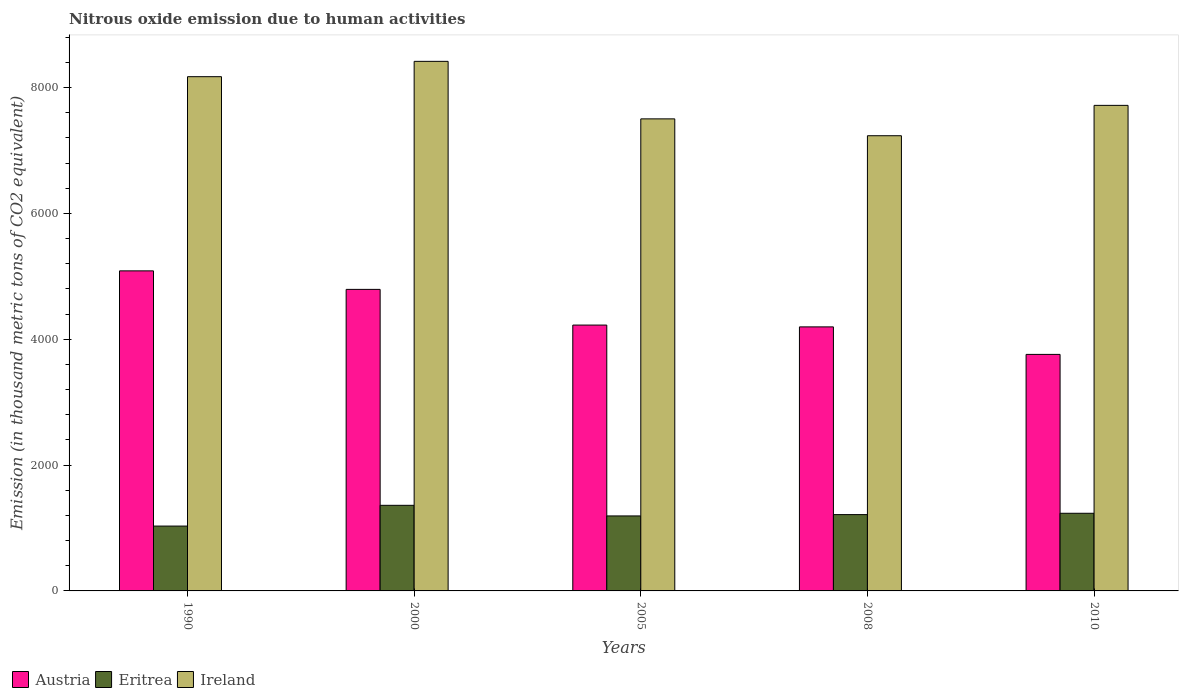How many different coloured bars are there?
Keep it short and to the point. 3. Are the number of bars per tick equal to the number of legend labels?
Your answer should be very brief. Yes. Are the number of bars on each tick of the X-axis equal?
Your answer should be compact. Yes. How many bars are there on the 3rd tick from the left?
Your answer should be compact. 3. How many bars are there on the 2nd tick from the right?
Your answer should be very brief. 3. What is the label of the 3rd group of bars from the left?
Give a very brief answer. 2005. In how many cases, is the number of bars for a given year not equal to the number of legend labels?
Make the answer very short. 0. What is the amount of nitrous oxide emitted in Eritrea in 1990?
Provide a short and direct response. 1030.6. Across all years, what is the maximum amount of nitrous oxide emitted in Austria?
Offer a terse response. 5086.3. Across all years, what is the minimum amount of nitrous oxide emitted in Austria?
Your answer should be compact. 3758.7. In which year was the amount of nitrous oxide emitted in Ireland minimum?
Offer a terse response. 2008. What is the total amount of nitrous oxide emitted in Ireland in the graph?
Keep it short and to the point. 3.90e+04. What is the difference between the amount of nitrous oxide emitted in Ireland in 2000 and that in 2005?
Make the answer very short. 914.1. What is the difference between the amount of nitrous oxide emitted in Eritrea in 2005 and the amount of nitrous oxide emitted in Ireland in 1990?
Your answer should be compact. -6980.4. What is the average amount of nitrous oxide emitted in Eritrea per year?
Provide a short and direct response. 1205.88. In the year 2005, what is the difference between the amount of nitrous oxide emitted in Ireland and amount of nitrous oxide emitted in Eritrea?
Your answer should be compact. 6309.9. What is the ratio of the amount of nitrous oxide emitted in Austria in 2005 to that in 2010?
Offer a very short reply. 1.12. What is the difference between the highest and the second highest amount of nitrous oxide emitted in Eritrea?
Make the answer very short. 126.3. What is the difference between the highest and the lowest amount of nitrous oxide emitted in Austria?
Provide a short and direct response. 1327.6. In how many years, is the amount of nitrous oxide emitted in Austria greater than the average amount of nitrous oxide emitted in Austria taken over all years?
Your answer should be compact. 2. Is the sum of the amount of nitrous oxide emitted in Eritrea in 2000 and 2008 greater than the maximum amount of nitrous oxide emitted in Austria across all years?
Make the answer very short. No. What does the 3rd bar from the left in 2008 represents?
Offer a very short reply. Ireland. What does the 3rd bar from the right in 1990 represents?
Offer a very short reply. Austria. Are the values on the major ticks of Y-axis written in scientific E-notation?
Your answer should be very brief. No. Does the graph contain any zero values?
Give a very brief answer. No. Does the graph contain grids?
Your answer should be compact. No. Where does the legend appear in the graph?
Give a very brief answer. Bottom left. How many legend labels are there?
Your answer should be very brief. 3. How are the legend labels stacked?
Keep it short and to the point. Horizontal. What is the title of the graph?
Offer a terse response. Nitrous oxide emission due to human activities. What is the label or title of the Y-axis?
Ensure brevity in your answer.  Emission (in thousand metric tons of CO2 equivalent). What is the Emission (in thousand metric tons of CO2 equivalent) in Austria in 1990?
Offer a terse response. 5086.3. What is the Emission (in thousand metric tons of CO2 equivalent) of Eritrea in 1990?
Offer a terse response. 1030.6. What is the Emission (in thousand metric tons of CO2 equivalent) in Ireland in 1990?
Offer a very short reply. 8172.1. What is the Emission (in thousand metric tons of CO2 equivalent) of Austria in 2000?
Your answer should be very brief. 4792. What is the Emission (in thousand metric tons of CO2 equivalent) in Eritrea in 2000?
Make the answer very short. 1360.3. What is the Emission (in thousand metric tons of CO2 equivalent) in Ireland in 2000?
Your response must be concise. 8415.7. What is the Emission (in thousand metric tons of CO2 equivalent) of Austria in 2005?
Your response must be concise. 4224.7. What is the Emission (in thousand metric tons of CO2 equivalent) in Eritrea in 2005?
Provide a succinct answer. 1191.7. What is the Emission (in thousand metric tons of CO2 equivalent) of Ireland in 2005?
Make the answer very short. 7501.6. What is the Emission (in thousand metric tons of CO2 equivalent) in Austria in 2008?
Provide a succinct answer. 4196.1. What is the Emission (in thousand metric tons of CO2 equivalent) of Eritrea in 2008?
Provide a succinct answer. 1212.8. What is the Emission (in thousand metric tons of CO2 equivalent) in Ireland in 2008?
Give a very brief answer. 7233.7. What is the Emission (in thousand metric tons of CO2 equivalent) in Austria in 2010?
Your answer should be very brief. 3758.7. What is the Emission (in thousand metric tons of CO2 equivalent) of Eritrea in 2010?
Give a very brief answer. 1234. What is the Emission (in thousand metric tons of CO2 equivalent) in Ireland in 2010?
Make the answer very short. 7716.3. Across all years, what is the maximum Emission (in thousand metric tons of CO2 equivalent) of Austria?
Make the answer very short. 5086.3. Across all years, what is the maximum Emission (in thousand metric tons of CO2 equivalent) in Eritrea?
Ensure brevity in your answer.  1360.3. Across all years, what is the maximum Emission (in thousand metric tons of CO2 equivalent) of Ireland?
Your answer should be compact. 8415.7. Across all years, what is the minimum Emission (in thousand metric tons of CO2 equivalent) of Austria?
Your answer should be compact. 3758.7. Across all years, what is the minimum Emission (in thousand metric tons of CO2 equivalent) in Eritrea?
Give a very brief answer. 1030.6. Across all years, what is the minimum Emission (in thousand metric tons of CO2 equivalent) in Ireland?
Offer a terse response. 7233.7. What is the total Emission (in thousand metric tons of CO2 equivalent) of Austria in the graph?
Make the answer very short. 2.21e+04. What is the total Emission (in thousand metric tons of CO2 equivalent) in Eritrea in the graph?
Give a very brief answer. 6029.4. What is the total Emission (in thousand metric tons of CO2 equivalent) of Ireland in the graph?
Your answer should be compact. 3.90e+04. What is the difference between the Emission (in thousand metric tons of CO2 equivalent) in Austria in 1990 and that in 2000?
Your answer should be very brief. 294.3. What is the difference between the Emission (in thousand metric tons of CO2 equivalent) of Eritrea in 1990 and that in 2000?
Give a very brief answer. -329.7. What is the difference between the Emission (in thousand metric tons of CO2 equivalent) in Ireland in 1990 and that in 2000?
Offer a terse response. -243.6. What is the difference between the Emission (in thousand metric tons of CO2 equivalent) of Austria in 1990 and that in 2005?
Keep it short and to the point. 861.6. What is the difference between the Emission (in thousand metric tons of CO2 equivalent) in Eritrea in 1990 and that in 2005?
Provide a short and direct response. -161.1. What is the difference between the Emission (in thousand metric tons of CO2 equivalent) in Ireland in 1990 and that in 2005?
Give a very brief answer. 670.5. What is the difference between the Emission (in thousand metric tons of CO2 equivalent) of Austria in 1990 and that in 2008?
Ensure brevity in your answer.  890.2. What is the difference between the Emission (in thousand metric tons of CO2 equivalent) in Eritrea in 1990 and that in 2008?
Your answer should be compact. -182.2. What is the difference between the Emission (in thousand metric tons of CO2 equivalent) in Ireland in 1990 and that in 2008?
Your answer should be very brief. 938.4. What is the difference between the Emission (in thousand metric tons of CO2 equivalent) in Austria in 1990 and that in 2010?
Offer a terse response. 1327.6. What is the difference between the Emission (in thousand metric tons of CO2 equivalent) in Eritrea in 1990 and that in 2010?
Give a very brief answer. -203.4. What is the difference between the Emission (in thousand metric tons of CO2 equivalent) of Ireland in 1990 and that in 2010?
Provide a succinct answer. 455.8. What is the difference between the Emission (in thousand metric tons of CO2 equivalent) in Austria in 2000 and that in 2005?
Offer a very short reply. 567.3. What is the difference between the Emission (in thousand metric tons of CO2 equivalent) of Eritrea in 2000 and that in 2005?
Offer a very short reply. 168.6. What is the difference between the Emission (in thousand metric tons of CO2 equivalent) of Ireland in 2000 and that in 2005?
Provide a succinct answer. 914.1. What is the difference between the Emission (in thousand metric tons of CO2 equivalent) in Austria in 2000 and that in 2008?
Your answer should be compact. 595.9. What is the difference between the Emission (in thousand metric tons of CO2 equivalent) of Eritrea in 2000 and that in 2008?
Give a very brief answer. 147.5. What is the difference between the Emission (in thousand metric tons of CO2 equivalent) of Ireland in 2000 and that in 2008?
Make the answer very short. 1182. What is the difference between the Emission (in thousand metric tons of CO2 equivalent) of Austria in 2000 and that in 2010?
Make the answer very short. 1033.3. What is the difference between the Emission (in thousand metric tons of CO2 equivalent) of Eritrea in 2000 and that in 2010?
Ensure brevity in your answer.  126.3. What is the difference between the Emission (in thousand metric tons of CO2 equivalent) in Ireland in 2000 and that in 2010?
Your answer should be compact. 699.4. What is the difference between the Emission (in thousand metric tons of CO2 equivalent) of Austria in 2005 and that in 2008?
Offer a terse response. 28.6. What is the difference between the Emission (in thousand metric tons of CO2 equivalent) of Eritrea in 2005 and that in 2008?
Give a very brief answer. -21.1. What is the difference between the Emission (in thousand metric tons of CO2 equivalent) in Ireland in 2005 and that in 2008?
Your response must be concise. 267.9. What is the difference between the Emission (in thousand metric tons of CO2 equivalent) of Austria in 2005 and that in 2010?
Provide a succinct answer. 466. What is the difference between the Emission (in thousand metric tons of CO2 equivalent) of Eritrea in 2005 and that in 2010?
Offer a very short reply. -42.3. What is the difference between the Emission (in thousand metric tons of CO2 equivalent) of Ireland in 2005 and that in 2010?
Provide a succinct answer. -214.7. What is the difference between the Emission (in thousand metric tons of CO2 equivalent) in Austria in 2008 and that in 2010?
Your answer should be compact. 437.4. What is the difference between the Emission (in thousand metric tons of CO2 equivalent) in Eritrea in 2008 and that in 2010?
Your answer should be very brief. -21.2. What is the difference between the Emission (in thousand metric tons of CO2 equivalent) of Ireland in 2008 and that in 2010?
Give a very brief answer. -482.6. What is the difference between the Emission (in thousand metric tons of CO2 equivalent) in Austria in 1990 and the Emission (in thousand metric tons of CO2 equivalent) in Eritrea in 2000?
Ensure brevity in your answer.  3726. What is the difference between the Emission (in thousand metric tons of CO2 equivalent) in Austria in 1990 and the Emission (in thousand metric tons of CO2 equivalent) in Ireland in 2000?
Your response must be concise. -3329.4. What is the difference between the Emission (in thousand metric tons of CO2 equivalent) in Eritrea in 1990 and the Emission (in thousand metric tons of CO2 equivalent) in Ireland in 2000?
Offer a terse response. -7385.1. What is the difference between the Emission (in thousand metric tons of CO2 equivalent) of Austria in 1990 and the Emission (in thousand metric tons of CO2 equivalent) of Eritrea in 2005?
Give a very brief answer. 3894.6. What is the difference between the Emission (in thousand metric tons of CO2 equivalent) in Austria in 1990 and the Emission (in thousand metric tons of CO2 equivalent) in Ireland in 2005?
Provide a succinct answer. -2415.3. What is the difference between the Emission (in thousand metric tons of CO2 equivalent) of Eritrea in 1990 and the Emission (in thousand metric tons of CO2 equivalent) of Ireland in 2005?
Your answer should be compact. -6471. What is the difference between the Emission (in thousand metric tons of CO2 equivalent) in Austria in 1990 and the Emission (in thousand metric tons of CO2 equivalent) in Eritrea in 2008?
Provide a short and direct response. 3873.5. What is the difference between the Emission (in thousand metric tons of CO2 equivalent) in Austria in 1990 and the Emission (in thousand metric tons of CO2 equivalent) in Ireland in 2008?
Offer a terse response. -2147.4. What is the difference between the Emission (in thousand metric tons of CO2 equivalent) in Eritrea in 1990 and the Emission (in thousand metric tons of CO2 equivalent) in Ireland in 2008?
Your answer should be compact. -6203.1. What is the difference between the Emission (in thousand metric tons of CO2 equivalent) in Austria in 1990 and the Emission (in thousand metric tons of CO2 equivalent) in Eritrea in 2010?
Provide a short and direct response. 3852.3. What is the difference between the Emission (in thousand metric tons of CO2 equivalent) of Austria in 1990 and the Emission (in thousand metric tons of CO2 equivalent) of Ireland in 2010?
Offer a terse response. -2630. What is the difference between the Emission (in thousand metric tons of CO2 equivalent) of Eritrea in 1990 and the Emission (in thousand metric tons of CO2 equivalent) of Ireland in 2010?
Provide a succinct answer. -6685.7. What is the difference between the Emission (in thousand metric tons of CO2 equivalent) of Austria in 2000 and the Emission (in thousand metric tons of CO2 equivalent) of Eritrea in 2005?
Make the answer very short. 3600.3. What is the difference between the Emission (in thousand metric tons of CO2 equivalent) of Austria in 2000 and the Emission (in thousand metric tons of CO2 equivalent) of Ireland in 2005?
Provide a succinct answer. -2709.6. What is the difference between the Emission (in thousand metric tons of CO2 equivalent) of Eritrea in 2000 and the Emission (in thousand metric tons of CO2 equivalent) of Ireland in 2005?
Provide a succinct answer. -6141.3. What is the difference between the Emission (in thousand metric tons of CO2 equivalent) in Austria in 2000 and the Emission (in thousand metric tons of CO2 equivalent) in Eritrea in 2008?
Your answer should be compact. 3579.2. What is the difference between the Emission (in thousand metric tons of CO2 equivalent) in Austria in 2000 and the Emission (in thousand metric tons of CO2 equivalent) in Ireland in 2008?
Make the answer very short. -2441.7. What is the difference between the Emission (in thousand metric tons of CO2 equivalent) in Eritrea in 2000 and the Emission (in thousand metric tons of CO2 equivalent) in Ireland in 2008?
Make the answer very short. -5873.4. What is the difference between the Emission (in thousand metric tons of CO2 equivalent) in Austria in 2000 and the Emission (in thousand metric tons of CO2 equivalent) in Eritrea in 2010?
Give a very brief answer. 3558. What is the difference between the Emission (in thousand metric tons of CO2 equivalent) of Austria in 2000 and the Emission (in thousand metric tons of CO2 equivalent) of Ireland in 2010?
Provide a short and direct response. -2924.3. What is the difference between the Emission (in thousand metric tons of CO2 equivalent) in Eritrea in 2000 and the Emission (in thousand metric tons of CO2 equivalent) in Ireland in 2010?
Offer a terse response. -6356. What is the difference between the Emission (in thousand metric tons of CO2 equivalent) in Austria in 2005 and the Emission (in thousand metric tons of CO2 equivalent) in Eritrea in 2008?
Your answer should be compact. 3011.9. What is the difference between the Emission (in thousand metric tons of CO2 equivalent) in Austria in 2005 and the Emission (in thousand metric tons of CO2 equivalent) in Ireland in 2008?
Provide a short and direct response. -3009. What is the difference between the Emission (in thousand metric tons of CO2 equivalent) of Eritrea in 2005 and the Emission (in thousand metric tons of CO2 equivalent) of Ireland in 2008?
Offer a terse response. -6042. What is the difference between the Emission (in thousand metric tons of CO2 equivalent) in Austria in 2005 and the Emission (in thousand metric tons of CO2 equivalent) in Eritrea in 2010?
Your answer should be very brief. 2990.7. What is the difference between the Emission (in thousand metric tons of CO2 equivalent) of Austria in 2005 and the Emission (in thousand metric tons of CO2 equivalent) of Ireland in 2010?
Keep it short and to the point. -3491.6. What is the difference between the Emission (in thousand metric tons of CO2 equivalent) in Eritrea in 2005 and the Emission (in thousand metric tons of CO2 equivalent) in Ireland in 2010?
Keep it short and to the point. -6524.6. What is the difference between the Emission (in thousand metric tons of CO2 equivalent) of Austria in 2008 and the Emission (in thousand metric tons of CO2 equivalent) of Eritrea in 2010?
Offer a terse response. 2962.1. What is the difference between the Emission (in thousand metric tons of CO2 equivalent) of Austria in 2008 and the Emission (in thousand metric tons of CO2 equivalent) of Ireland in 2010?
Give a very brief answer. -3520.2. What is the difference between the Emission (in thousand metric tons of CO2 equivalent) in Eritrea in 2008 and the Emission (in thousand metric tons of CO2 equivalent) in Ireland in 2010?
Provide a short and direct response. -6503.5. What is the average Emission (in thousand metric tons of CO2 equivalent) in Austria per year?
Offer a very short reply. 4411.56. What is the average Emission (in thousand metric tons of CO2 equivalent) of Eritrea per year?
Offer a terse response. 1205.88. What is the average Emission (in thousand metric tons of CO2 equivalent) in Ireland per year?
Your answer should be very brief. 7807.88. In the year 1990, what is the difference between the Emission (in thousand metric tons of CO2 equivalent) in Austria and Emission (in thousand metric tons of CO2 equivalent) in Eritrea?
Keep it short and to the point. 4055.7. In the year 1990, what is the difference between the Emission (in thousand metric tons of CO2 equivalent) in Austria and Emission (in thousand metric tons of CO2 equivalent) in Ireland?
Provide a short and direct response. -3085.8. In the year 1990, what is the difference between the Emission (in thousand metric tons of CO2 equivalent) of Eritrea and Emission (in thousand metric tons of CO2 equivalent) of Ireland?
Give a very brief answer. -7141.5. In the year 2000, what is the difference between the Emission (in thousand metric tons of CO2 equivalent) in Austria and Emission (in thousand metric tons of CO2 equivalent) in Eritrea?
Give a very brief answer. 3431.7. In the year 2000, what is the difference between the Emission (in thousand metric tons of CO2 equivalent) of Austria and Emission (in thousand metric tons of CO2 equivalent) of Ireland?
Provide a short and direct response. -3623.7. In the year 2000, what is the difference between the Emission (in thousand metric tons of CO2 equivalent) in Eritrea and Emission (in thousand metric tons of CO2 equivalent) in Ireland?
Give a very brief answer. -7055.4. In the year 2005, what is the difference between the Emission (in thousand metric tons of CO2 equivalent) in Austria and Emission (in thousand metric tons of CO2 equivalent) in Eritrea?
Your answer should be compact. 3033. In the year 2005, what is the difference between the Emission (in thousand metric tons of CO2 equivalent) in Austria and Emission (in thousand metric tons of CO2 equivalent) in Ireland?
Your response must be concise. -3276.9. In the year 2005, what is the difference between the Emission (in thousand metric tons of CO2 equivalent) in Eritrea and Emission (in thousand metric tons of CO2 equivalent) in Ireland?
Give a very brief answer. -6309.9. In the year 2008, what is the difference between the Emission (in thousand metric tons of CO2 equivalent) of Austria and Emission (in thousand metric tons of CO2 equivalent) of Eritrea?
Give a very brief answer. 2983.3. In the year 2008, what is the difference between the Emission (in thousand metric tons of CO2 equivalent) of Austria and Emission (in thousand metric tons of CO2 equivalent) of Ireland?
Provide a succinct answer. -3037.6. In the year 2008, what is the difference between the Emission (in thousand metric tons of CO2 equivalent) of Eritrea and Emission (in thousand metric tons of CO2 equivalent) of Ireland?
Your answer should be compact. -6020.9. In the year 2010, what is the difference between the Emission (in thousand metric tons of CO2 equivalent) of Austria and Emission (in thousand metric tons of CO2 equivalent) of Eritrea?
Your response must be concise. 2524.7. In the year 2010, what is the difference between the Emission (in thousand metric tons of CO2 equivalent) of Austria and Emission (in thousand metric tons of CO2 equivalent) of Ireland?
Provide a short and direct response. -3957.6. In the year 2010, what is the difference between the Emission (in thousand metric tons of CO2 equivalent) of Eritrea and Emission (in thousand metric tons of CO2 equivalent) of Ireland?
Make the answer very short. -6482.3. What is the ratio of the Emission (in thousand metric tons of CO2 equivalent) of Austria in 1990 to that in 2000?
Provide a succinct answer. 1.06. What is the ratio of the Emission (in thousand metric tons of CO2 equivalent) of Eritrea in 1990 to that in 2000?
Ensure brevity in your answer.  0.76. What is the ratio of the Emission (in thousand metric tons of CO2 equivalent) in Ireland in 1990 to that in 2000?
Your answer should be compact. 0.97. What is the ratio of the Emission (in thousand metric tons of CO2 equivalent) in Austria in 1990 to that in 2005?
Your response must be concise. 1.2. What is the ratio of the Emission (in thousand metric tons of CO2 equivalent) of Eritrea in 1990 to that in 2005?
Offer a very short reply. 0.86. What is the ratio of the Emission (in thousand metric tons of CO2 equivalent) in Ireland in 1990 to that in 2005?
Your answer should be very brief. 1.09. What is the ratio of the Emission (in thousand metric tons of CO2 equivalent) in Austria in 1990 to that in 2008?
Your response must be concise. 1.21. What is the ratio of the Emission (in thousand metric tons of CO2 equivalent) in Eritrea in 1990 to that in 2008?
Provide a short and direct response. 0.85. What is the ratio of the Emission (in thousand metric tons of CO2 equivalent) of Ireland in 1990 to that in 2008?
Your response must be concise. 1.13. What is the ratio of the Emission (in thousand metric tons of CO2 equivalent) in Austria in 1990 to that in 2010?
Your answer should be very brief. 1.35. What is the ratio of the Emission (in thousand metric tons of CO2 equivalent) of Eritrea in 1990 to that in 2010?
Give a very brief answer. 0.84. What is the ratio of the Emission (in thousand metric tons of CO2 equivalent) of Ireland in 1990 to that in 2010?
Offer a terse response. 1.06. What is the ratio of the Emission (in thousand metric tons of CO2 equivalent) in Austria in 2000 to that in 2005?
Offer a very short reply. 1.13. What is the ratio of the Emission (in thousand metric tons of CO2 equivalent) in Eritrea in 2000 to that in 2005?
Ensure brevity in your answer.  1.14. What is the ratio of the Emission (in thousand metric tons of CO2 equivalent) in Ireland in 2000 to that in 2005?
Ensure brevity in your answer.  1.12. What is the ratio of the Emission (in thousand metric tons of CO2 equivalent) in Austria in 2000 to that in 2008?
Give a very brief answer. 1.14. What is the ratio of the Emission (in thousand metric tons of CO2 equivalent) of Eritrea in 2000 to that in 2008?
Ensure brevity in your answer.  1.12. What is the ratio of the Emission (in thousand metric tons of CO2 equivalent) of Ireland in 2000 to that in 2008?
Provide a short and direct response. 1.16. What is the ratio of the Emission (in thousand metric tons of CO2 equivalent) of Austria in 2000 to that in 2010?
Provide a short and direct response. 1.27. What is the ratio of the Emission (in thousand metric tons of CO2 equivalent) of Eritrea in 2000 to that in 2010?
Offer a very short reply. 1.1. What is the ratio of the Emission (in thousand metric tons of CO2 equivalent) in Ireland in 2000 to that in 2010?
Your response must be concise. 1.09. What is the ratio of the Emission (in thousand metric tons of CO2 equivalent) of Austria in 2005 to that in 2008?
Keep it short and to the point. 1.01. What is the ratio of the Emission (in thousand metric tons of CO2 equivalent) of Eritrea in 2005 to that in 2008?
Provide a succinct answer. 0.98. What is the ratio of the Emission (in thousand metric tons of CO2 equivalent) of Ireland in 2005 to that in 2008?
Make the answer very short. 1.04. What is the ratio of the Emission (in thousand metric tons of CO2 equivalent) in Austria in 2005 to that in 2010?
Provide a short and direct response. 1.12. What is the ratio of the Emission (in thousand metric tons of CO2 equivalent) of Eritrea in 2005 to that in 2010?
Keep it short and to the point. 0.97. What is the ratio of the Emission (in thousand metric tons of CO2 equivalent) of Ireland in 2005 to that in 2010?
Your answer should be very brief. 0.97. What is the ratio of the Emission (in thousand metric tons of CO2 equivalent) of Austria in 2008 to that in 2010?
Offer a very short reply. 1.12. What is the ratio of the Emission (in thousand metric tons of CO2 equivalent) of Eritrea in 2008 to that in 2010?
Keep it short and to the point. 0.98. What is the difference between the highest and the second highest Emission (in thousand metric tons of CO2 equivalent) of Austria?
Offer a terse response. 294.3. What is the difference between the highest and the second highest Emission (in thousand metric tons of CO2 equivalent) in Eritrea?
Provide a succinct answer. 126.3. What is the difference between the highest and the second highest Emission (in thousand metric tons of CO2 equivalent) in Ireland?
Keep it short and to the point. 243.6. What is the difference between the highest and the lowest Emission (in thousand metric tons of CO2 equivalent) in Austria?
Offer a terse response. 1327.6. What is the difference between the highest and the lowest Emission (in thousand metric tons of CO2 equivalent) of Eritrea?
Ensure brevity in your answer.  329.7. What is the difference between the highest and the lowest Emission (in thousand metric tons of CO2 equivalent) of Ireland?
Your answer should be compact. 1182. 